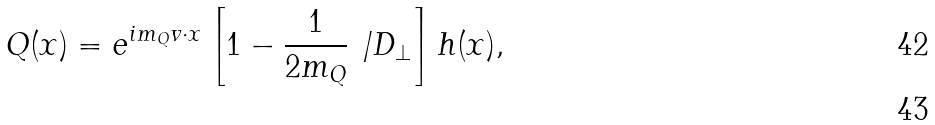<formula> <loc_0><loc_0><loc_500><loc_500>Q ( x ) = e ^ { i m _ { Q } v \cdot x } \left [ 1 - \frac { 1 } { 2 m _ { Q } } \not { \, D _ { \perp } } \right ] h ( x ) , \\</formula> 